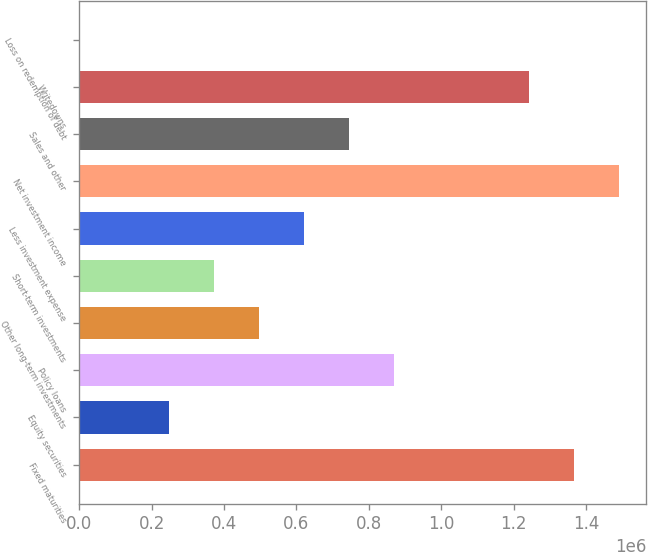Convert chart to OTSL. <chart><loc_0><loc_0><loc_500><loc_500><bar_chart><fcel>Fixed maturities<fcel>Equity securities<fcel>Policy loans<fcel>Other long-term investments<fcel>Short-term investments<fcel>Less investment expense<fcel>Net investment income<fcel>Sales and other<fcel>Writedowns<fcel>Loss on redemption of debt<nl><fcel>1.36747e+06<fcel>248632<fcel>870211<fcel>497264<fcel>372948<fcel>621580<fcel>1.49179e+06<fcel>745895<fcel>1.24316e+06<fcel>1<nl></chart> 